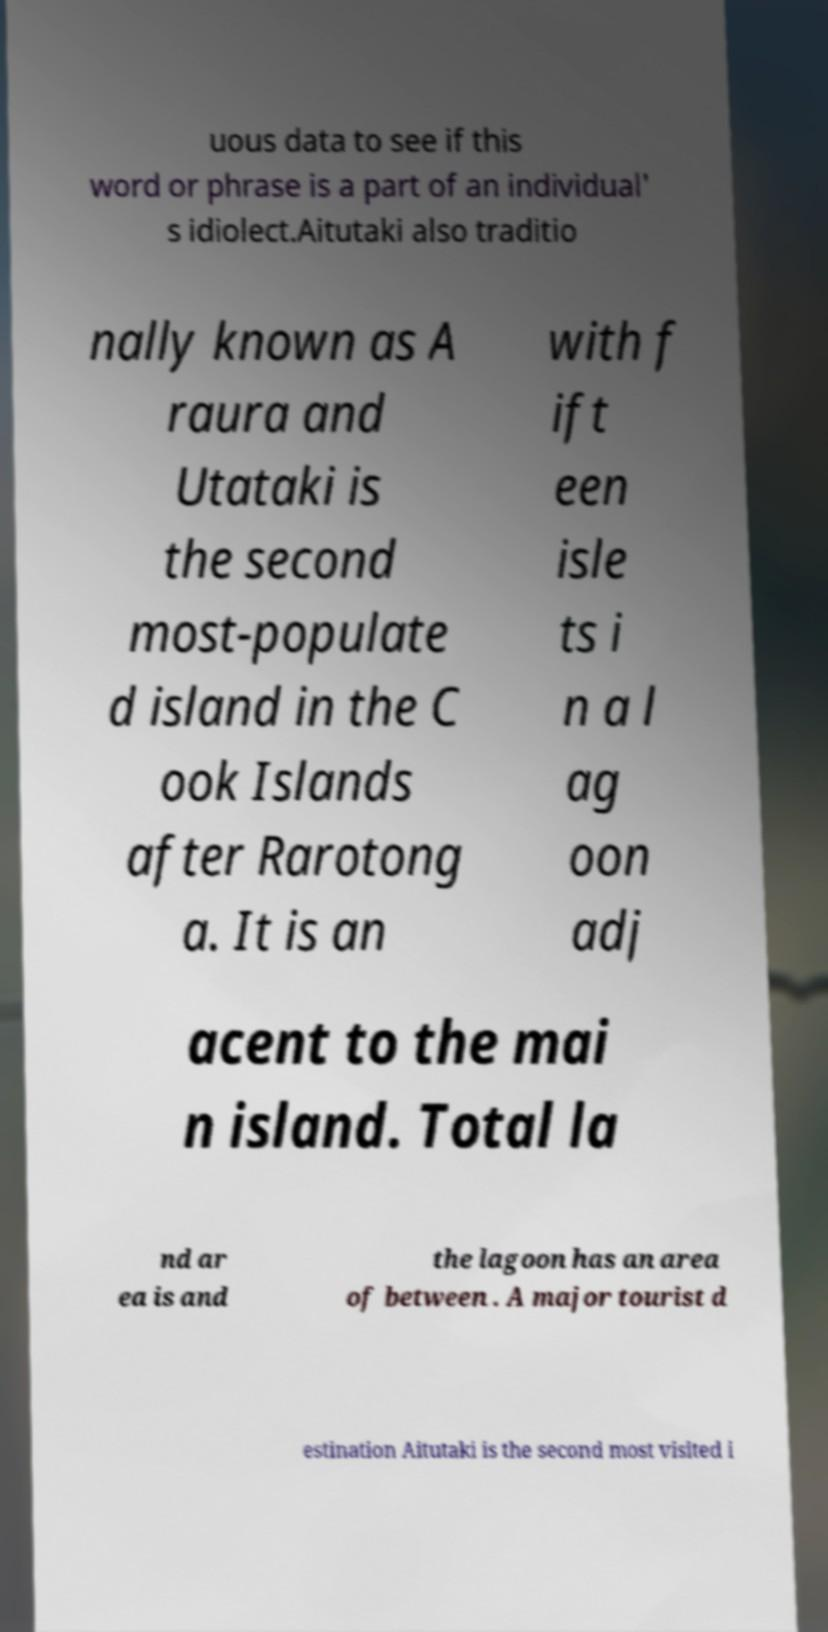Could you extract and type out the text from this image? uous data to see if this word or phrase is a part of an individual' s idiolect.Aitutaki also traditio nally known as A raura and Utataki is the second most-populate d island in the C ook Islands after Rarotong a. It is an with f ift een isle ts i n a l ag oon adj acent to the mai n island. Total la nd ar ea is and the lagoon has an area of between . A major tourist d estination Aitutaki is the second most visited i 